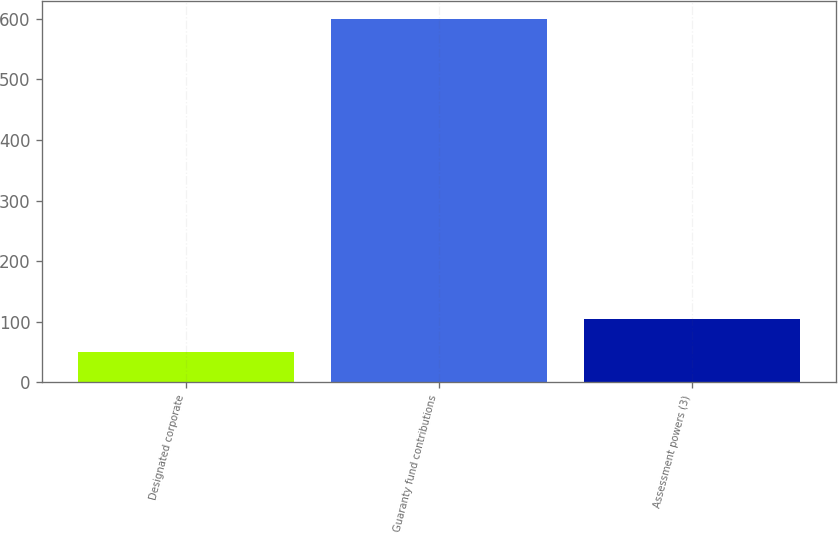<chart> <loc_0><loc_0><loc_500><loc_500><bar_chart><fcel>Designated corporate<fcel>Guaranty fund contributions<fcel>Assessment powers (3)<nl><fcel>50<fcel>600<fcel>105<nl></chart> 